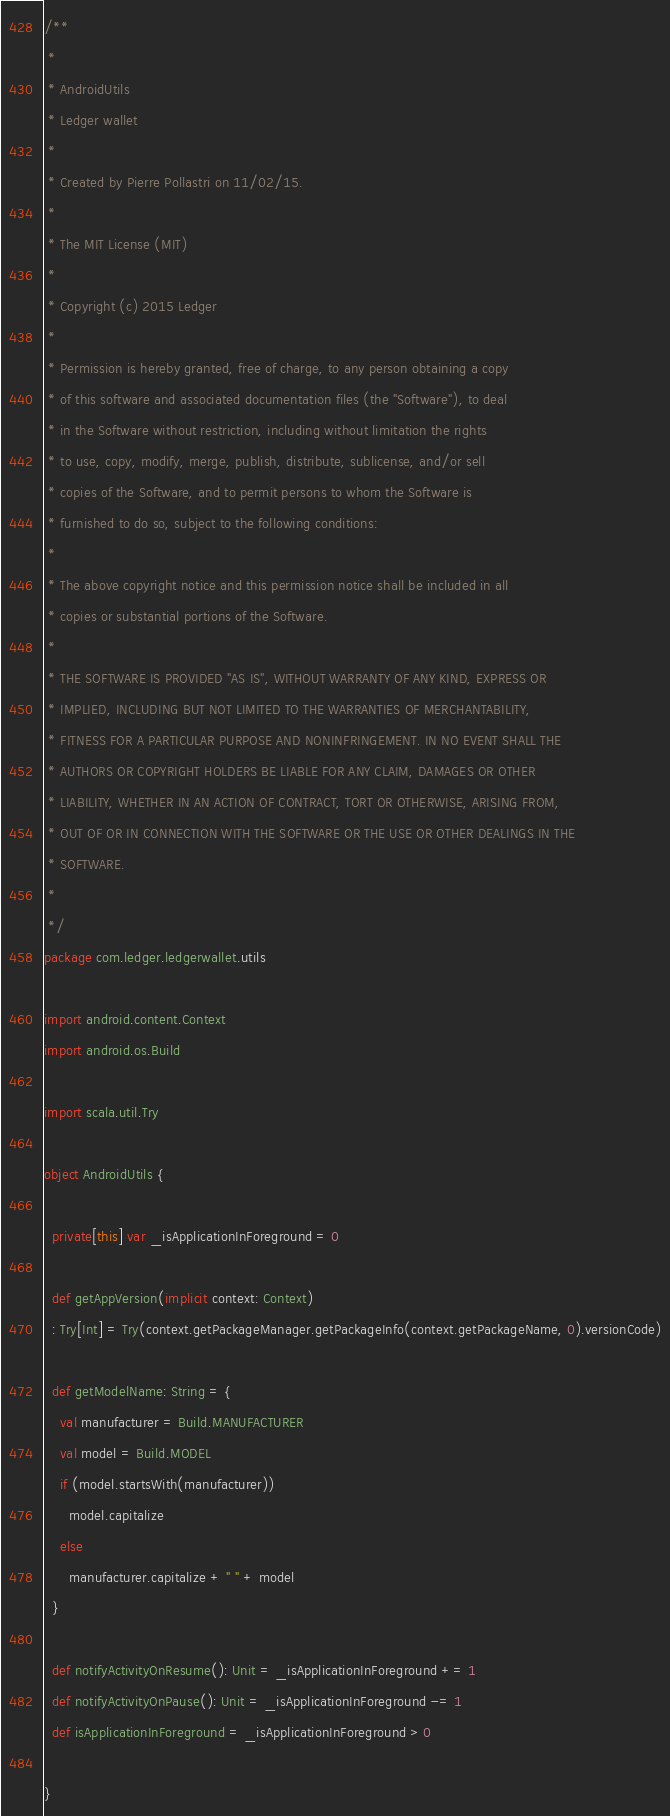<code> <loc_0><loc_0><loc_500><loc_500><_Scala_>/**
 *
 * AndroidUtils
 * Ledger wallet
 *
 * Created by Pierre Pollastri on 11/02/15.
 *
 * The MIT License (MIT)
 *
 * Copyright (c) 2015 Ledger
 *
 * Permission is hereby granted, free of charge, to any person obtaining a copy
 * of this software and associated documentation files (the "Software"), to deal
 * in the Software without restriction, including without limitation the rights
 * to use, copy, modify, merge, publish, distribute, sublicense, and/or sell
 * copies of the Software, and to permit persons to whom the Software is
 * furnished to do so, subject to the following conditions:
 *
 * The above copyright notice and this permission notice shall be included in all
 * copies or substantial portions of the Software.
 *
 * THE SOFTWARE IS PROVIDED "AS IS", WITHOUT WARRANTY OF ANY KIND, EXPRESS OR
 * IMPLIED, INCLUDING BUT NOT LIMITED TO THE WARRANTIES OF MERCHANTABILITY,
 * FITNESS FOR A PARTICULAR PURPOSE AND NONINFRINGEMENT. IN NO EVENT SHALL THE
 * AUTHORS OR COPYRIGHT HOLDERS BE LIABLE FOR ANY CLAIM, DAMAGES OR OTHER
 * LIABILITY, WHETHER IN AN ACTION OF CONTRACT, TORT OR OTHERWISE, ARISING FROM,
 * OUT OF OR IN CONNECTION WITH THE SOFTWARE OR THE USE OR OTHER DEALINGS IN THE
 * SOFTWARE.
 *
 */
package com.ledger.ledgerwallet.utils

import android.content.Context
import android.os.Build

import scala.util.Try

object AndroidUtils {

  private[this] var _isApplicationInForeground = 0

  def getAppVersion(implicit context: Context)
  : Try[Int] = Try(context.getPackageManager.getPackageInfo(context.getPackageName, 0).versionCode)

  def getModelName: String = {
    val manufacturer = Build.MANUFACTURER
    val model = Build.MODEL
    if (model.startsWith(manufacturer))
      model.capitalize
    else
      manufacturer.capitalize + " " + model
  }

  def notifyActivityOnResume(): Unit = _isApplicationInForeground += 1
  def notifyActivityOnPause(): Unit = _isApplicationInForeground -= 1
  def isApplicationInForeground = _isApplicationInForeground > 0

}
</code> 